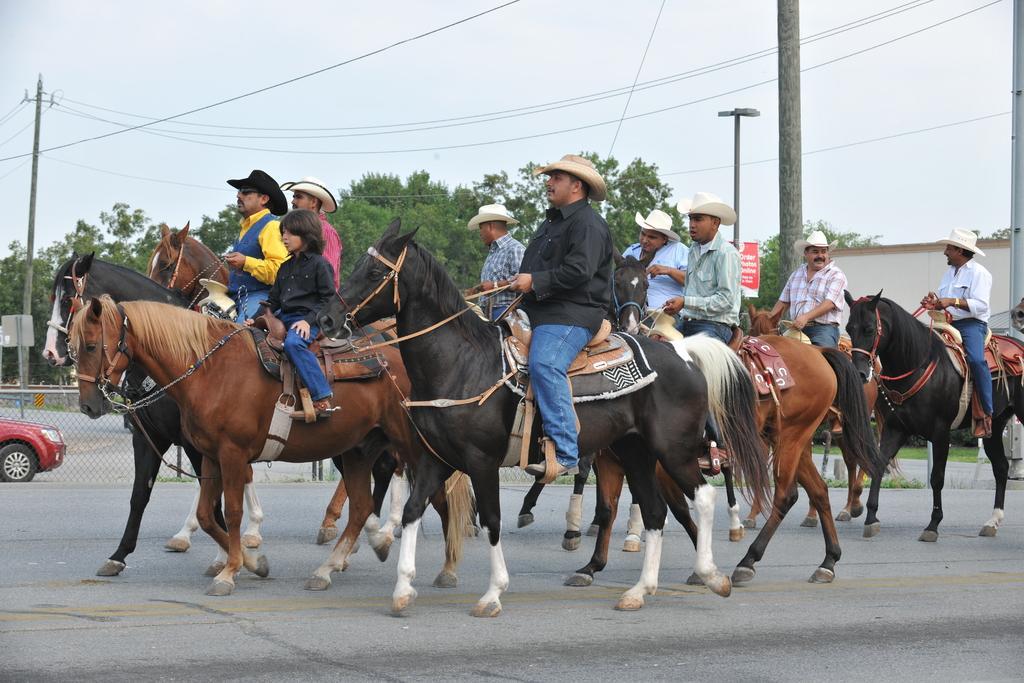How would you summarize this image in a sentence or two? In the image there are group of people travelling on the the horses and behind the people there are few poles in between and in the background there are many trees. 